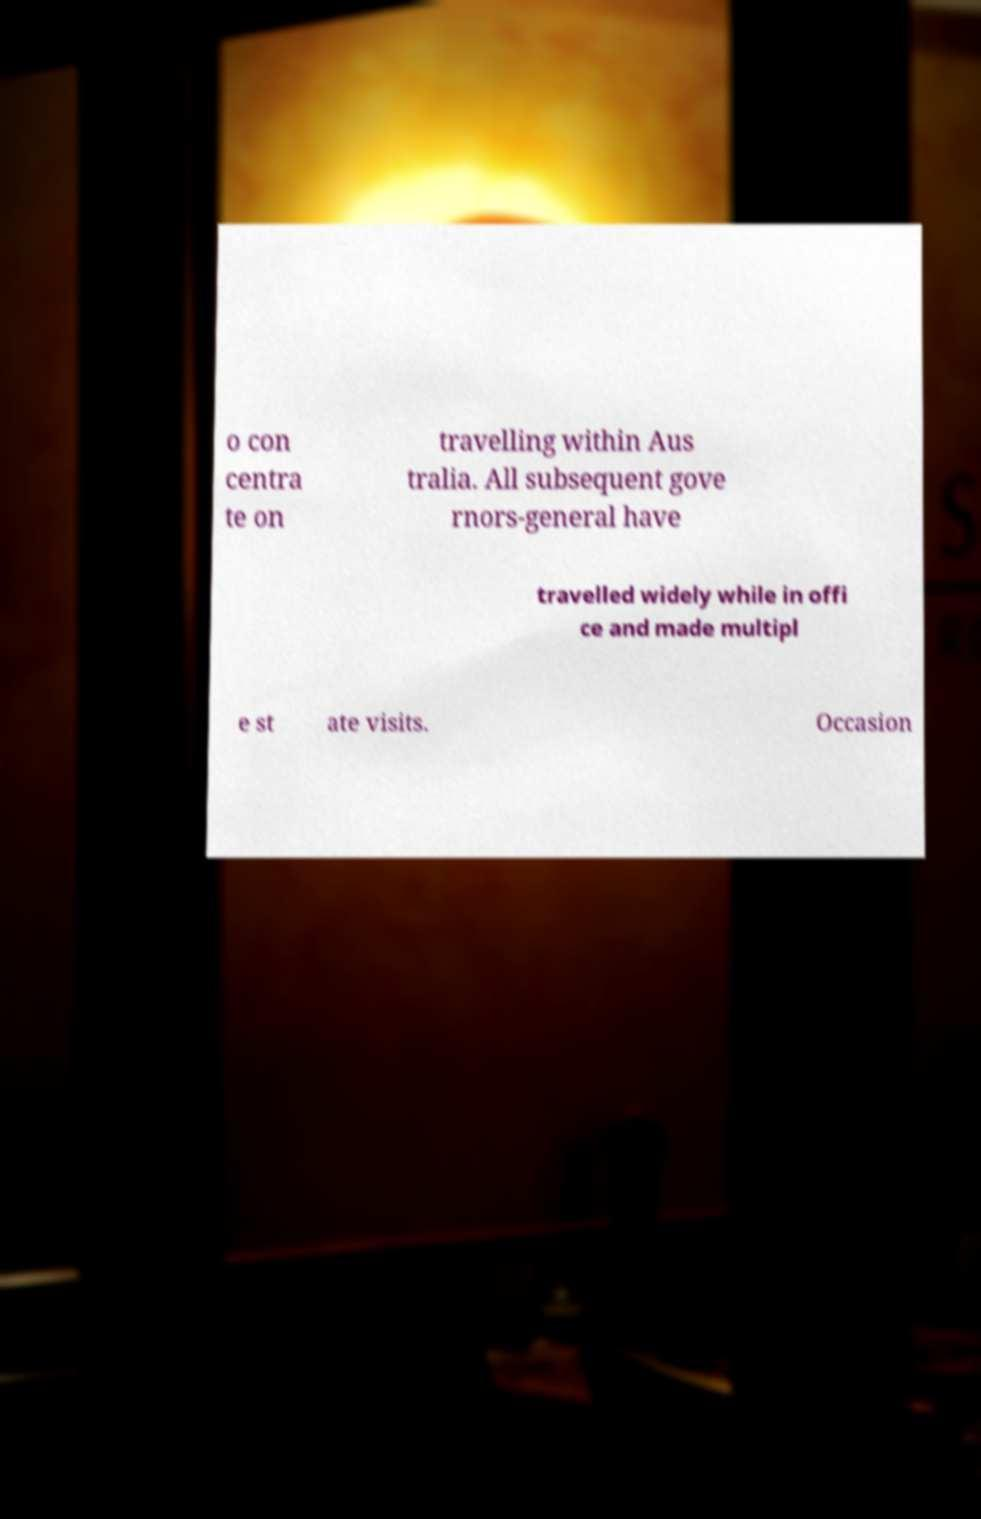Can you read and provide the text displayed in the image?This photo seems to have some interesting text. Can you extract and type it out for me? o con centra te on travelling within Aus tralia. All subsequent gove rnors-general have travelled widely while in offi ce and made multipl e st ate visits. Occasion 